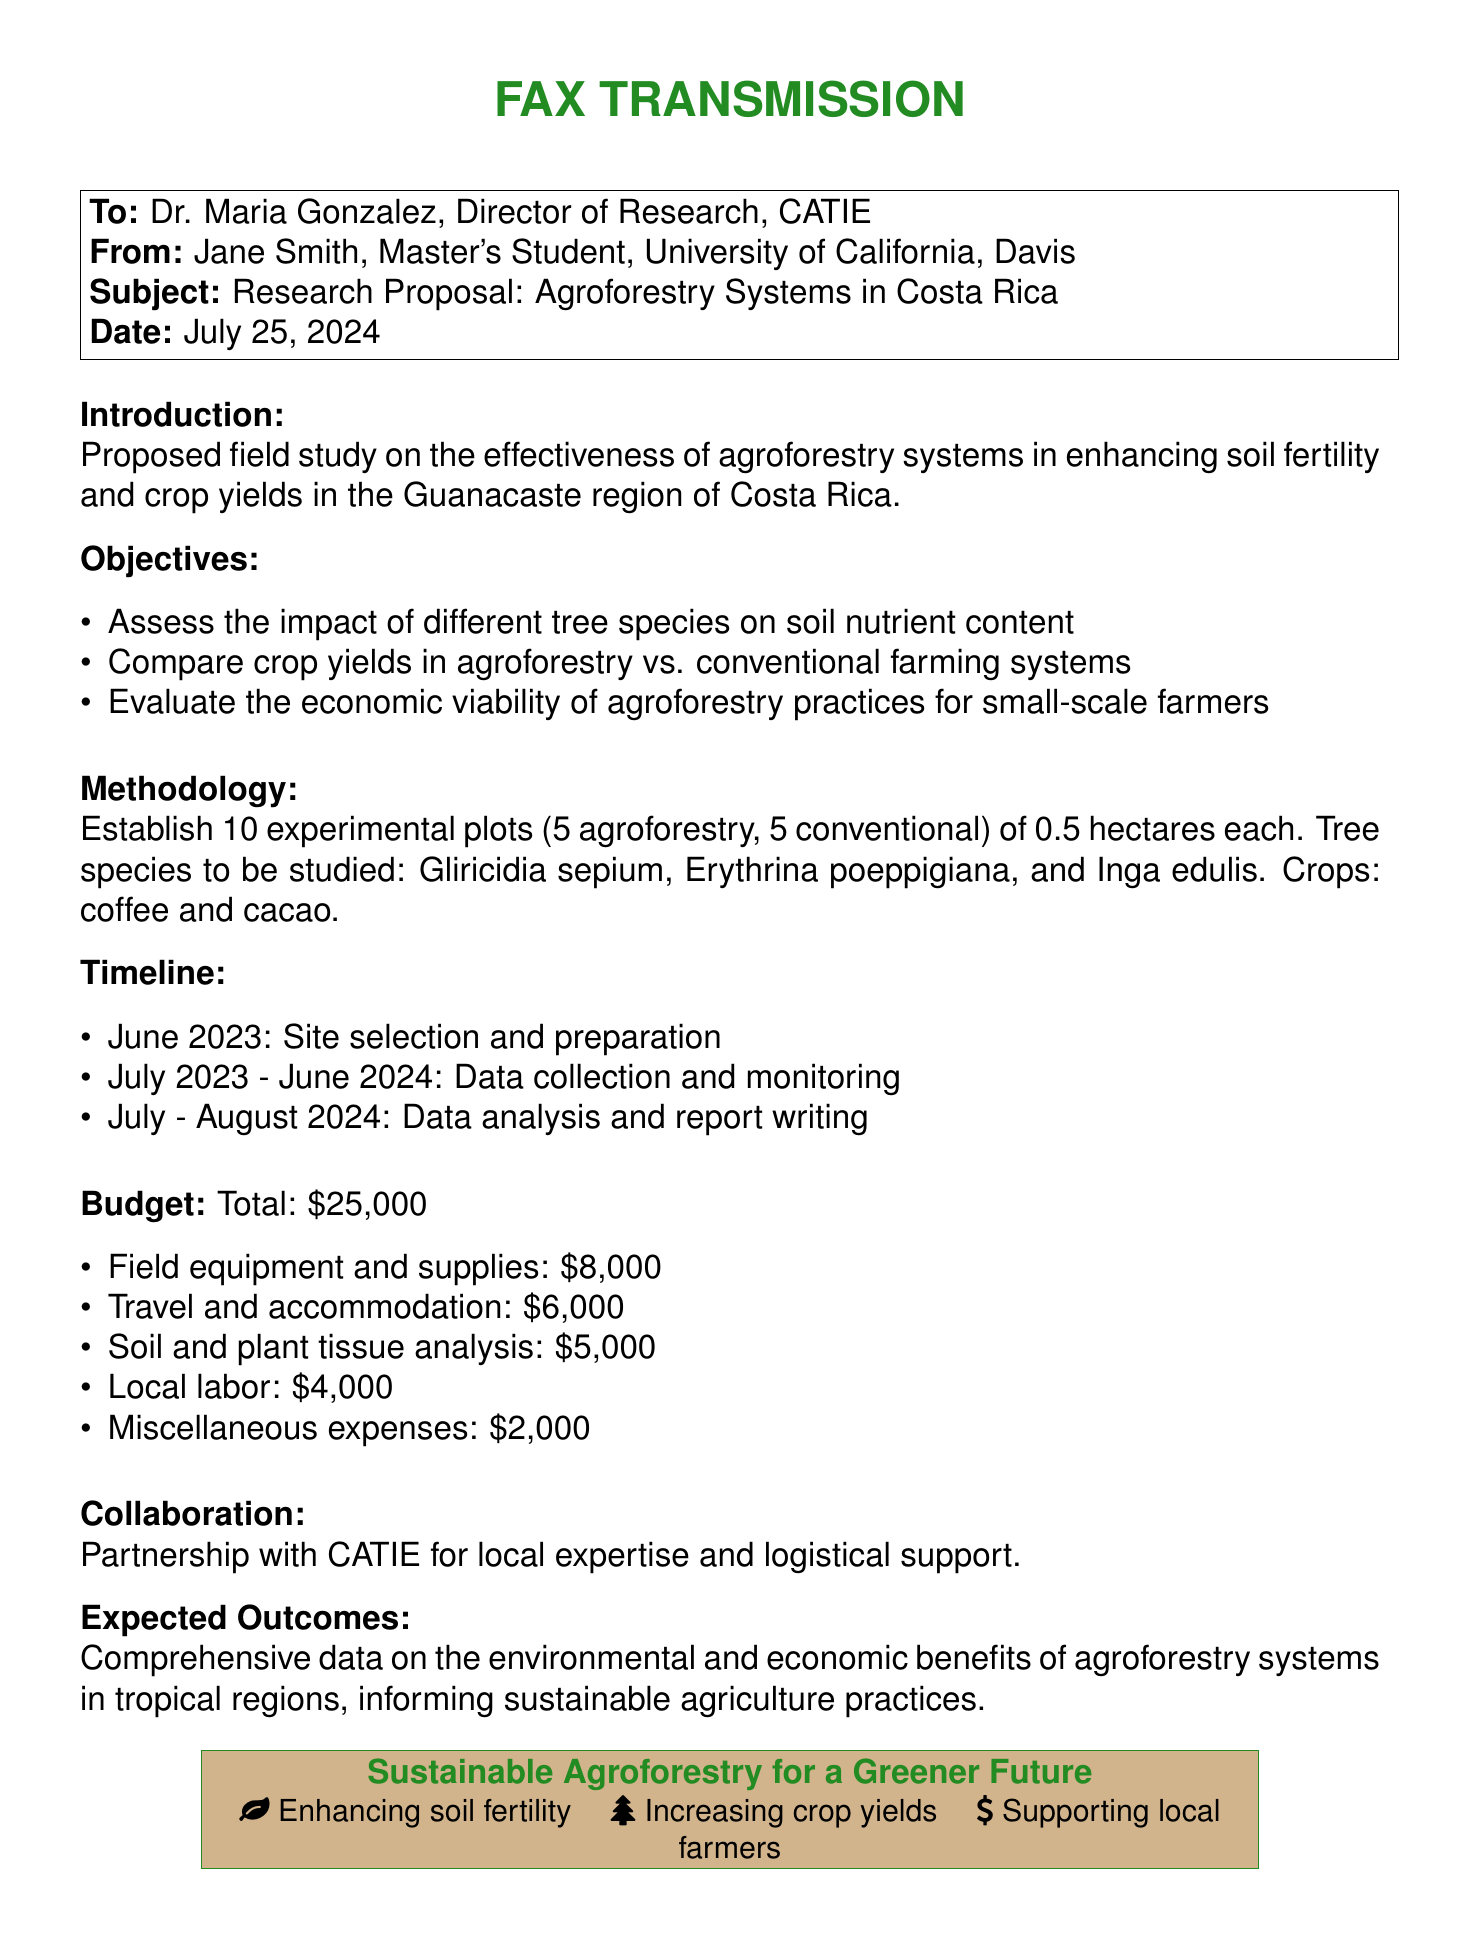What is the main focus of the research proposal? The main focus is on the effectiveness of agroforestry systems in enhancing soil fertility and crop yields.
Answer: Agroforestry systems Who is the recipient of this fax? The recipient of the fax is Dr. Maria Gonzalez, Director of Research, CATIE.
Answer: Dr. Maria Gonzalez What is the total budget for the project? The total budget is listed in the document as $25,000.
Answer: $25,000 What crops will be studied in the experimental plots? The crops to be studied are coffee and cacao.
Answer: Coffee and cacao When does the data collection begin? Data collection begins in July 2023.
Answer: July 2023 What tree species are included in the study? The tree species mentioned are Gliricidia sepium, Erythrina poeppigiana, and Inga edulis.
Answer: Gliricidia sepium, Erythrina poeppigiana, Inga edulis What is the duration of data analysis and report writing? The duration for data analysis and report writing is two months, from July to August 2024.
Answer: Two months What is the estimated cost for soil and plant tissue analysis? The estimated cost for soil and plant tissue analysis is $5,000.
Answer: $5,000 What is the primary expected outcome of the research? The primary expected outcome is comprehensive data on the environmental and economic benefits of agroforestry systems.
Answer: Comprehensive data on benefits 